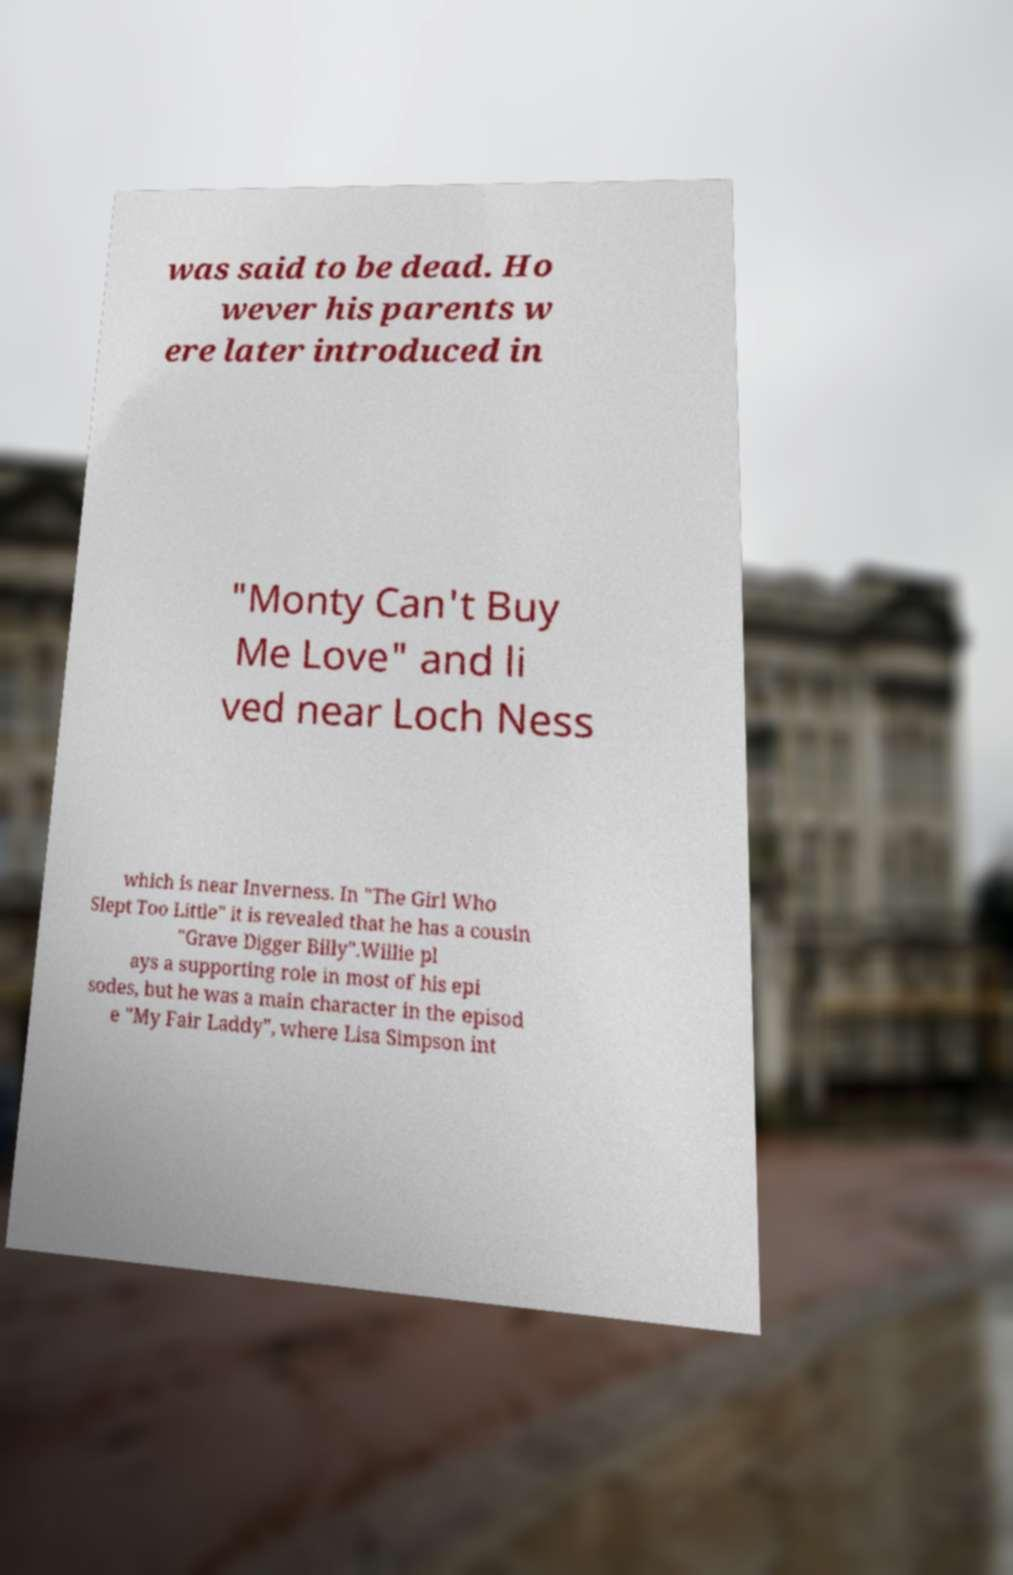Please read and relay the text visible in this image. What does it say? was said to be dead. Ho wever his parents w ere later introduced in "Monty Can't Buy Me Love" and li ved near Loch Ness which is near Inverness. In "The Girl Who Slept Too Little" it is revealed that he has a cousin "Grave Digger Billy".Willie pl ays a supporting role in most of his epi sodes, but he was a main character in the episod e "My Fair Laddy", where Lisa Simpson int 